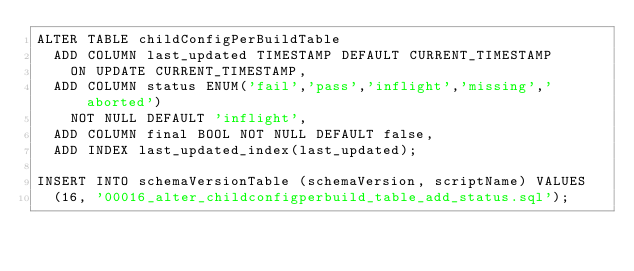Convert code to text. <code><loc_0><loc_0><loc_500><loc_500><_SQL_>ALTER TABLE childConfigPerBuildTable
  ADD COLUMN last_updated TIMESTAMP DEFAULT CURRENT_TIMESTAMP
    ON UPDATE CURRENT_TIMESTAMP,
  ADD COLUMN status ENUM('fail','pass','inflight','missing','aborted')
    NOT NULL DEFAULT 'inflight',
  ADD COLUMN final BOOL NOT NULL DEFAULT false,
  ADD INDEX last_updated_index(last_updated);

INSERT INTO schemaVersionTable (schemaVersion, scriptName) VALUES
  (16, '00016_alter_childconfigperbuild_table_add_status.sql');
</code> 